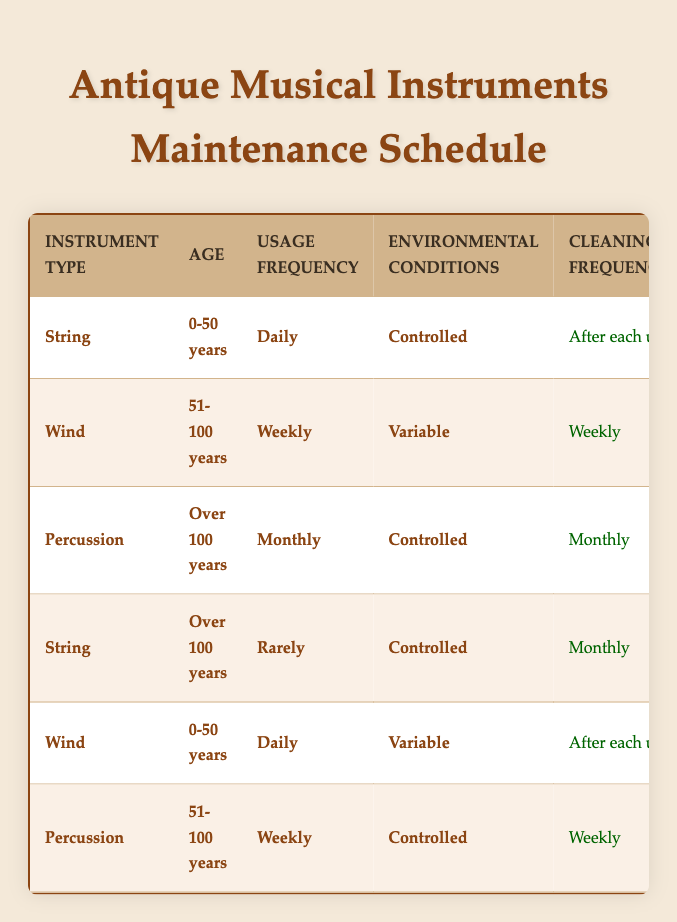What is the cleaning frequency for string instruments under 50 years of age that are used daily in controlled environments? According to the table, string instruments that are 0-50 years old and used daily in controlled environments need to be cleaned after each use.
Answer: After each use How often should percussion instruments over 100 years old be inspected? The table indicates that percussion instruments over 100 years are inspected every 2 years.
Answer: Every 2 years Does wind instrument maintenance require monitoring humidity for instruments aged 51-100 years that are used weekly in variable conditions? Yes, as per the table, wind instruments aged 51-100 years and used weekly in variable conditions are required to monitor humidity daily.
Answer: Yes What is the lubrication schedule for string instruments over 100 years with rare usage in controlled environments? For string instruments over 100 years old that are rarely used in controlled environments, lubrication is done annually, as indicated in the table.
Answer: Annually Which type of instrument requires a professional inspection every 5 years under controlled conditions? The table shows that percussion instruments aged 51-100 years require professional inspection every 5 years when used under controlled conditions.
Answer: Percussion instruments aged 51-100 years How many different cleaning frequencies are listed for wind instruments based on age and usage frequency? By examining the table, wind instruments can have two cleaning frequencies: "weekly" and "after each use," based on their age and usage frequency. So there are two different frequencies.
Answer: Two What is the maximum lubrication frequency for instruments aged 0-50 years that are played daily in variable conditions? The table specifies that for wind instruments aged 0-50 and played daily in variable conditions, lubrication frequency is monthly. This is the only applicable frequency under these conditions.
Answer: Monthly Are string instruments older than 100 years that are used rarely in controlled environments required to replace strings or reeds annually? Yes, the table notes that string instruments over 100 years old, rarely used in controlled environments, require restringing or reed replacement as needed, not annually.
Answer: No What is the difference in cleaning frequency between string instruments of 0-50 years used daily and percussion instruments over 100 years used monthly in controlled environments? For string instruments 0-50 years old used daily, cleaning frequency is after each use. For percussion instruments over 100 years, cleaning frequency is monthly. Therefore, the difference is the frequency of cleaning: “after each use” vs. “monthly.”
Answer: After each use vs. monthly 